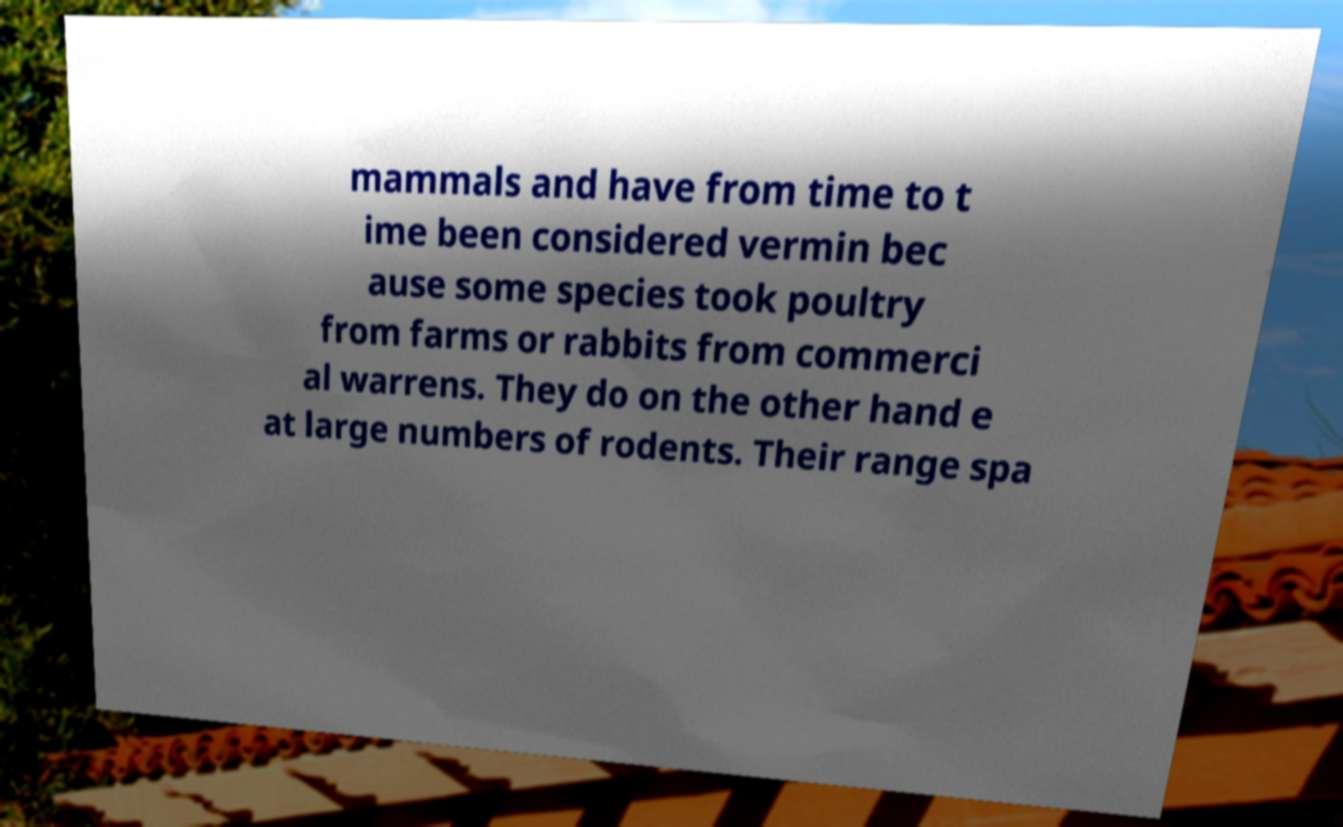Could you extract and type out the text from this image? mammals and have from time to t ime been considered vermin bec ause some species took poultry from farms or rabbits from commerci al warrens. They do on the other hand e at large numbers of rodents. Their range spa 